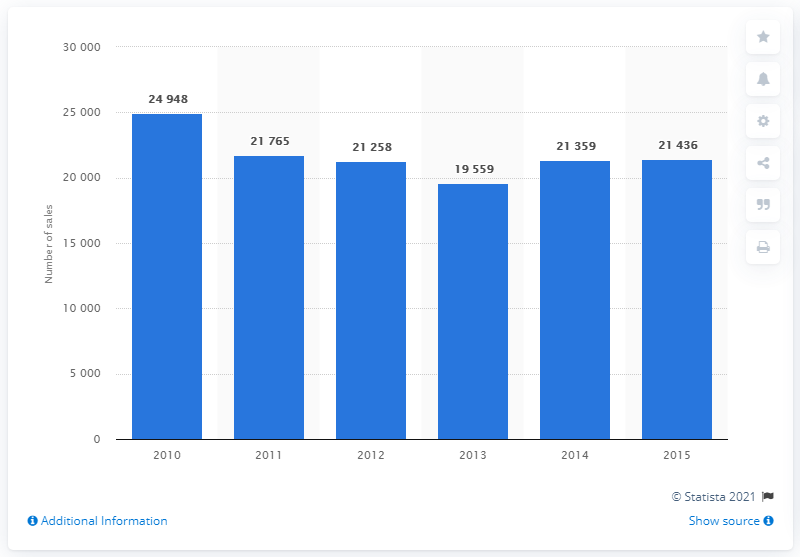Draw attention to some important aspects in this diagram. In 2013, the number of new tourers sold at retail in the UK was 19,559. In 2014, the number of new motorhomes sold at retail in the UK was 21,436. 